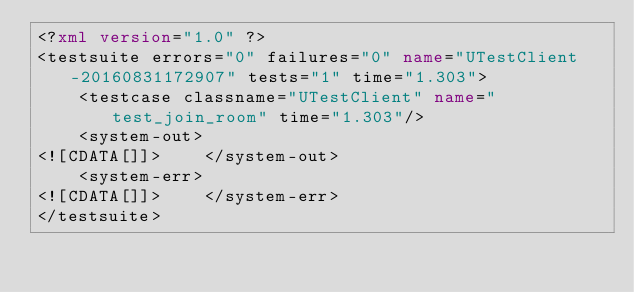Convert code to text. <code><loc_0><loc_0><loc_500><loc_500><_XML_><?xml version="1.0" ?>
<testsuite errors="0" failures="0" name="UTestClient-20160831172907" tests="1" time="1.303">
	<testcase classname="UTestClient" name="test_join_room" time="1.303"/>
	<system-out>
<![CDATA[]]>	</system-out>
	<system-err>
<![CDATA[]]>	</system-err>
</testsuite>
</code> 